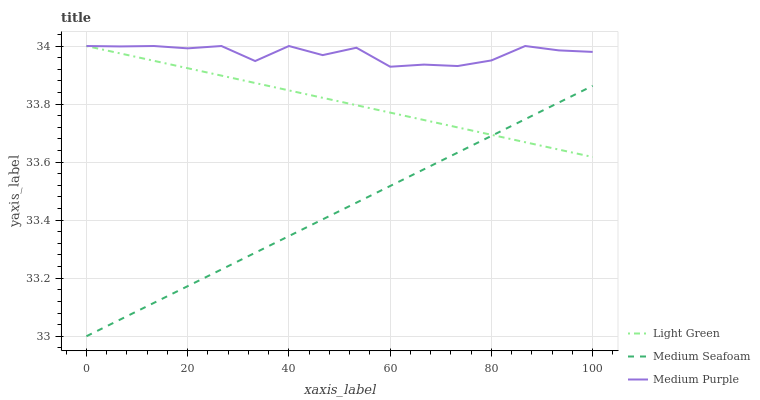Does Medium Seafoam have the minimum area under the curve?
Answer yes or no. Yes. Does Medium Purple have the maximum area under the curve?
Answer yes or no. Yes. Does Light Green have the minimum area under the curve?
Answer yes or no. No. Does Light Green have the maximum area under the curve?
Answer yes or no. No. Is Light Green the smoothest?
Answer yes or no. Yes. Is Medium Purple the roughest?
Answer yes or no. Yes. Is Medium Seafoam the smoothest?
Answer yes or no. No. Is Medium Seafoam the roughest?
Answer yes or no. No. Does Medium Seafoam have the lowest value?
Answer yes or no. Yes. Does Light Green have the lowest value?
Answer yes or no. No. Does Light Green have the highest value?
Answer yes or no. Yes. Does Medium Seafoam have the highest value?
Answer yes or no. No. Is Medium Seafoam less than Medium Purple?
Answer yes or no. Yes. Is Medium Purple greater than Medium Seafoam?
Answer yes or no. Yes. Does Light Green intersect Medium Purple?
Answer yes or no. Yes. Is Light Green less than Medium Purple?
Answer yes or no. No. Is Light Green greater than Medium Purple?
Answer yes or no. No. Does Medium Seafoam intersect Medium Purple?
Answer yes or no. No. 